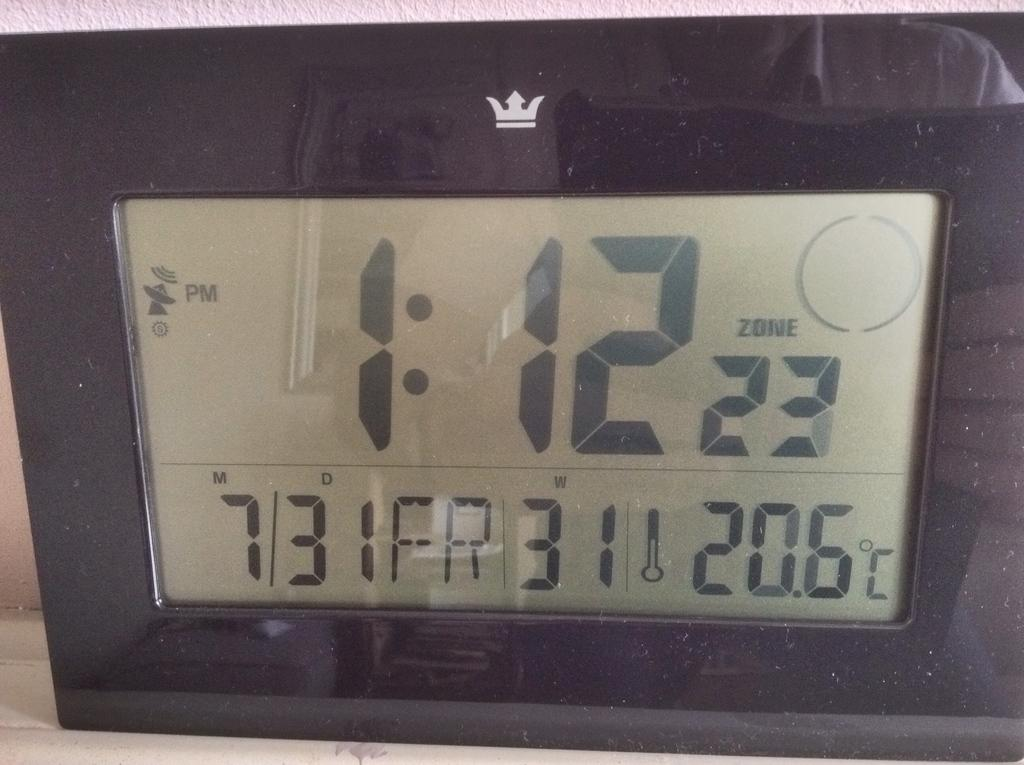<image>
Give a short and clear explanation of the subsequent image. Digital clock that has the time at 1:12. 